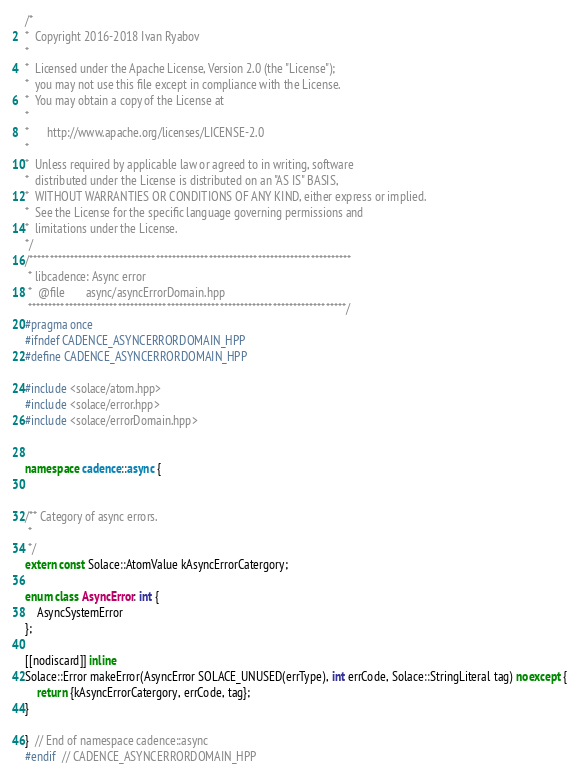Convert code to text. <code><loc_0><loc_0><loc_500><loc_500><_C++_>/*
*  Copyright 2016-2018 Ivan Ryabov
*
*  Licensed under the Apache License, Version 2.0 (the "License");
*  you may not use this file except in compliance with the License.
*  You may obtain a copy of the License at
*
*      http://www.apache.org/licenses/LICENSE-2.0
*
*  Unless required by applicable law or agreed to in writing, software
*  distributed under the License is distributed on an "AS IS" BASIS,
*  WITHOUT WARRANTIES OR CONDITIONS OF ANY KIND, either express or implied.
*  See the License for the specific language governing permissions and
*  limitations under the License.
*/
/*******************************************************************************
 * libcadence: Async error
 *	@file		async/asyncErrorDomain.hpp
 ******************************************************************************/
#pragma once
#ifndef CADENCE_ASYNCERRORDOMAIN_HPP
#define CADENCE_ASYNCERRORDOMAIN_HPP

#include <solace/atom.hpp>
#include <solace/error.hpp>
#include <solace/errorDomain.hpp>


namespace cadence::async {


/** Category of async errors.
 *
 */
extern const Solace::AtomValue kAsyncErrorCatergory;

enum class AsyncError: int {
    AsyncSystemError
};

[[nodiscard]] inline
Solace::Error makeError(AsyncError SOLACE_UNUSED(errType), int errCode, Solace::StringLiteral tag) noexcept {
    return {kAsyncErrorCatergory, errCode, tag};
}

}  // End of namespace cadence::async
#endif  // CADENCE_ASYNCERRORDOMAIN_HPP
</code> 